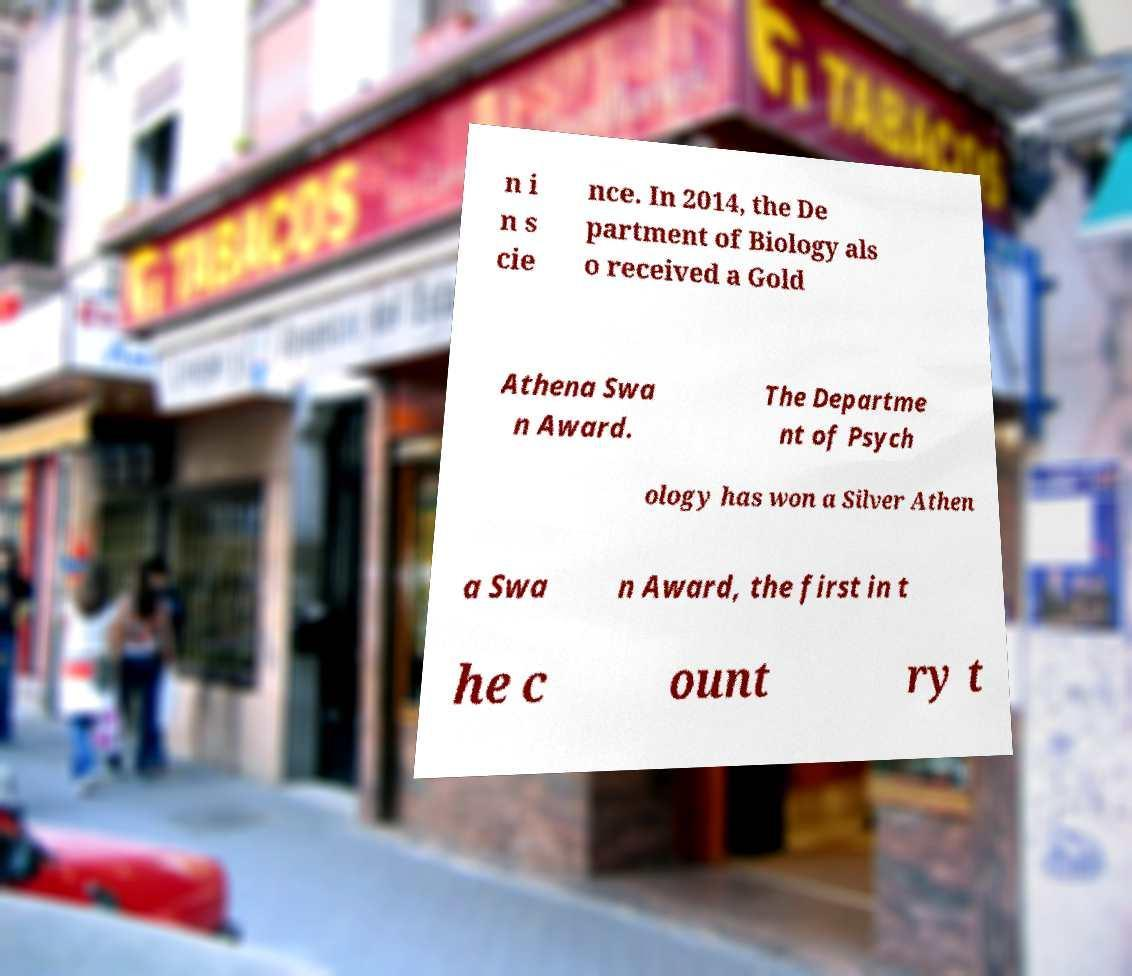For documentation purposes, I need the text within this image transcribed. Could you provide that? n i n s cie nce. In 2014, the De partment of Biology als o received a Gold Athena Swa n Award. The Departme nt of Psych ology has won a Silver Athen a Swa n Award, the first in t he c ount ry t 